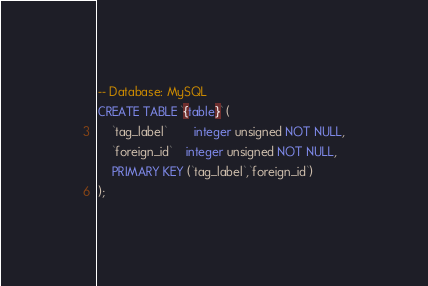Convert code to text. <code><loc_0><loc_0><loc_500><loc_500><_SQL_>-- Database: MySQL
CREATE TABLE `{table}` (
	`tag_label`		integer unsigned NOT NULL,
	`foreign_id`	integer unsigned NOT NULL,
	PRIMARY KEY (`tag_label`,`foreign_id`)
);</code> 